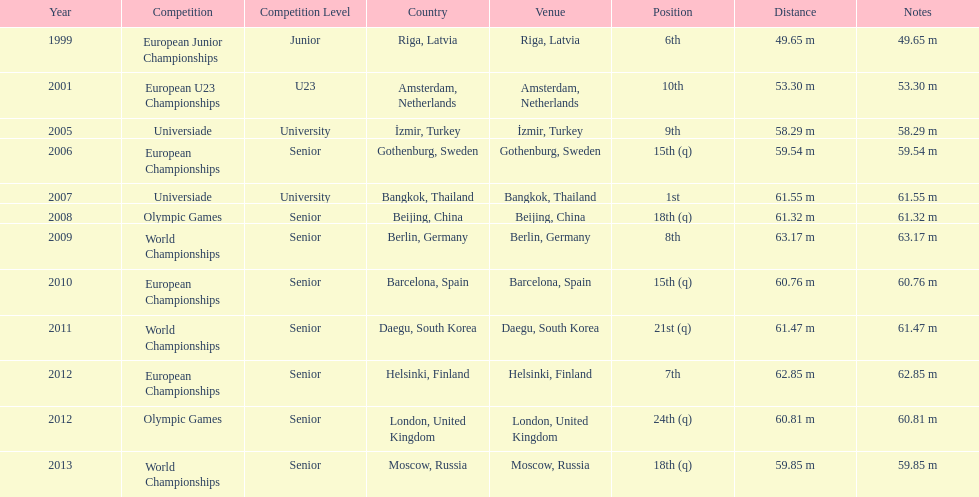Which year saw a recorded distance of merely 5 2001. 